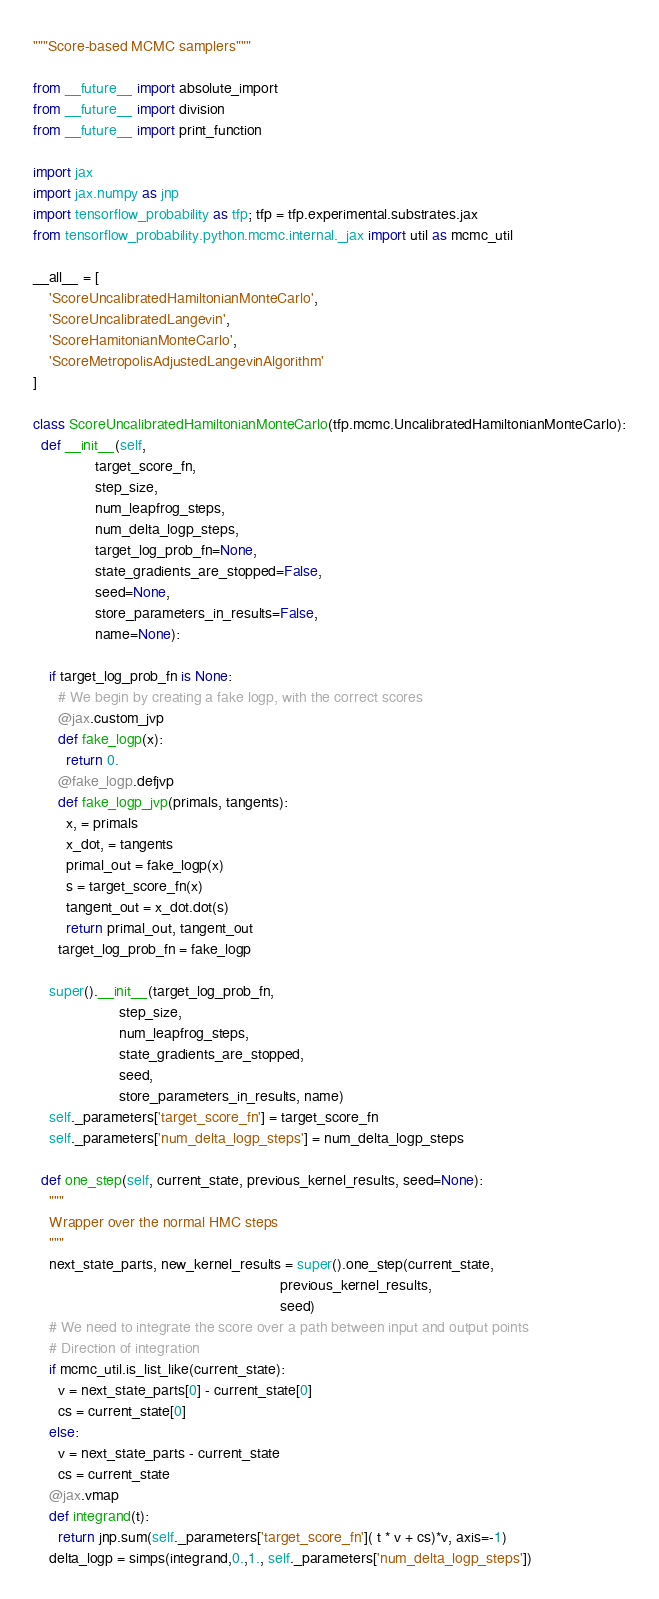<code> <loc_0><loc_0><loc_500><loc_500><_Python_>"""Score-based MCMC samplers"""

from __future__ import absolute_import
from __future__ import division
from __future__ import print_function

import jax
import jax.numpy as jnp
import tensorflow_probability as tfp; tfp = tfp.experimental.substrates.jax
from tensorflow_probability.python.mcmc.internal._jax import util as mcmc_util

__all__ = [
    'ScoreUncalibratedHamiltonianMonteCarlo',
    'ScoreUncalibratedLangevin',
    'ScoreHamitonianMonteCarlo',
    'ScoreMetropolisAdjustedLangevinAlgorithm'
]

class ScoreUncalibratedHamiltonianMonteCarlo(tfp.mcmc.UncalibratedHamiltonianMonteCarlo):
  def __init__(self,
               target_score_fn,
               step_size,
               num_leapfrog_steps,
               num_delta_logp_steps,
               target_log_prob_fn=None,
               state_gradients_are_stopped=False,
               seed=None,
               store_parameters_in_results=False,
               name=None):

    if target_log_prob_fn is None:
      # We begin by creating a fake logp, with the correct scores
      @jax.custom_jvp
      def fake_logp(x):
        return 0.
      @fake_logp.defjvp
      def fake_logp_jvp(primals, tangents):
        x, = primals
        x_dot, = tangents
        primal_out = fake_logp(x)
        s = target_score_fn(x)
        tangent_out = x_dot.dot(s)
        return primal_out, tangent_out
      target_log_prob_fn = fake_logp

    super().__init__(target_log_prob_fn,
                     step_size,
                     num_leapfrog_steps,
                     state_gradients_are_stopped,
                     seed,
                     store_parameters_in_results, name)
    self._parameters['target_score_fn'] = target_score_fn
    self._parameters['num_delta_logp_steps'] = num_delta_logp_steps

  def one_step(self, current_state, previous_kernel_results, seed=None):
    """
    Wrapper over the normal HMC steps
    """
    next_state_parts, new_kernel_results = super().one_step(current_state,
                                                            previous_kernel_results,
                                                            seed)
    # We need to integrate the score over a path between input and output points
    # Direction of integration
    if mcmc_util.is_list_like(current_state):
      v = next_state_parts[0] - current_state[0]
      cs = current_state[0]
    else:
      v = next_state_parts - current_state
      cs = current_state
    @jax.vmap
    def integrand(t):
      return jnp.sum(self._parameters['target_score_fn']( t * v + cs)*v, axis=-1)
    delta_logp = simps(integrand,0.,1., self._parameters['num_delta_logp_steps'])</code> 